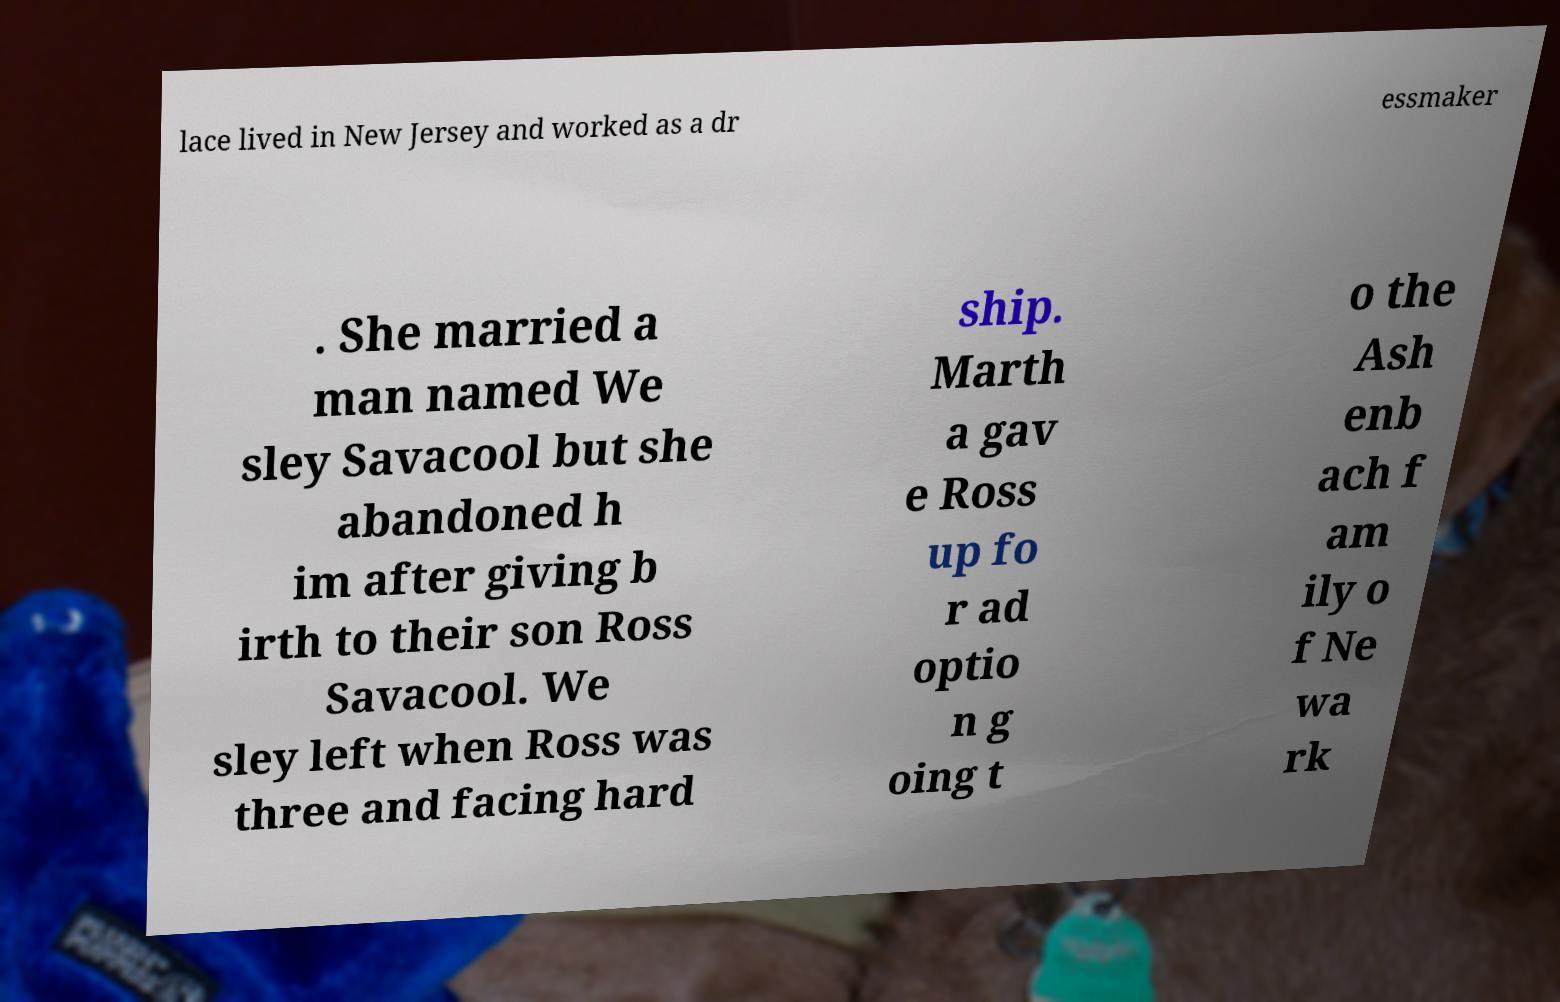I need the written content from this picture converted into text. Can you do that? lace lived in New Jersey and worked as a dr essmaker . She married a man named We sley Savacool but she abandoned h im after giving b irth to their son Ross Savacool. We sley left when Ross was three and facing hard ship. Marth a gav e Ross up fo r ad optio n g oing t o the Ash enb ach f am ily o f Ne wa rk 